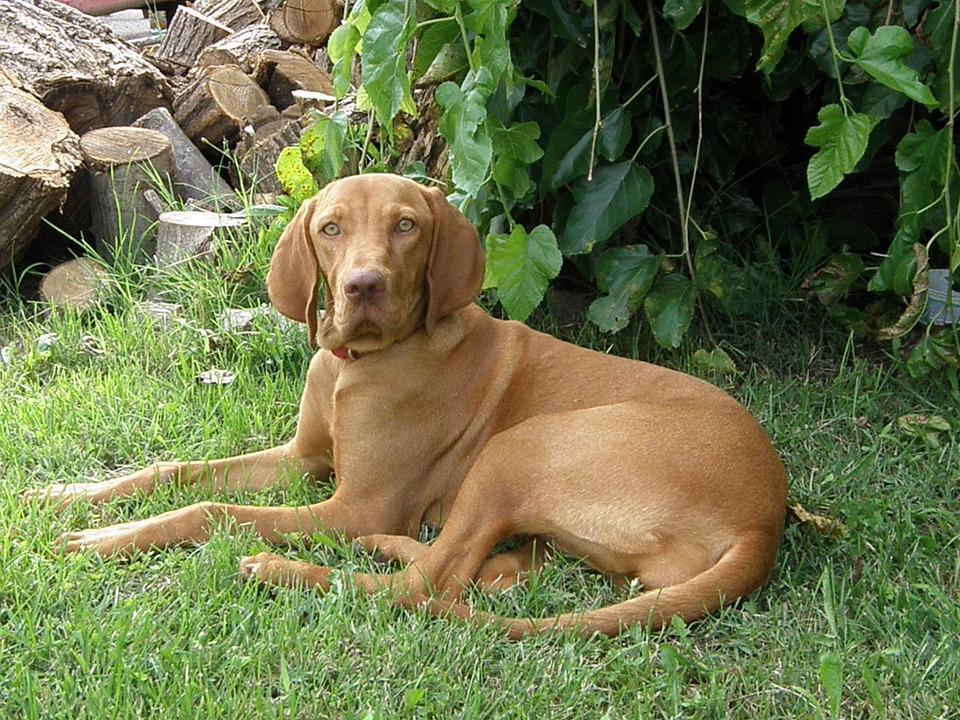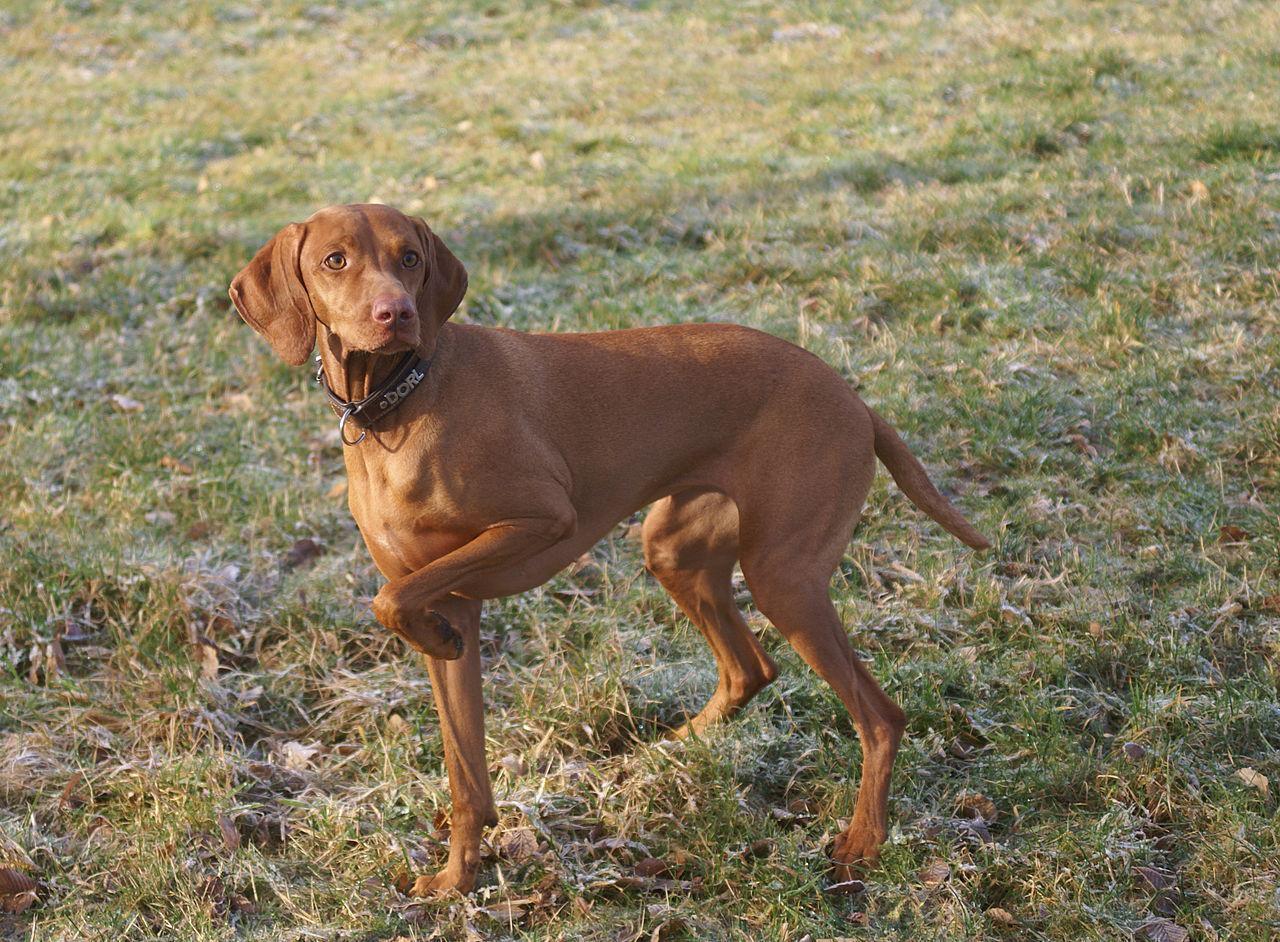The first image is the image on the left, the second image is the image on the right. Analyze the images presented: Is the assertion "The dog in the image on the right is standing with a front leg off the ground." valid? Answer yes or no. Yes. The first image is the image on the left, the second image is the image on the right. For the images displayed, is the sentence "The dogs in both images are holding one of their paws up off the ground." factually correct? Answer yes or no. No. 